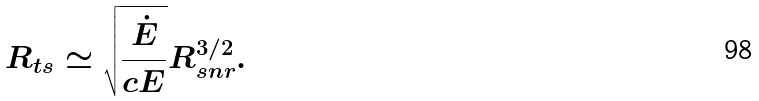<formula> <loc_0><loc_0><loc_500><loc_500>R _ { t s } \simeq \sqrt { \frac { \dot { E } } { c E } } R _ { s n r } ^ { 3 / 2 } .</formula> 